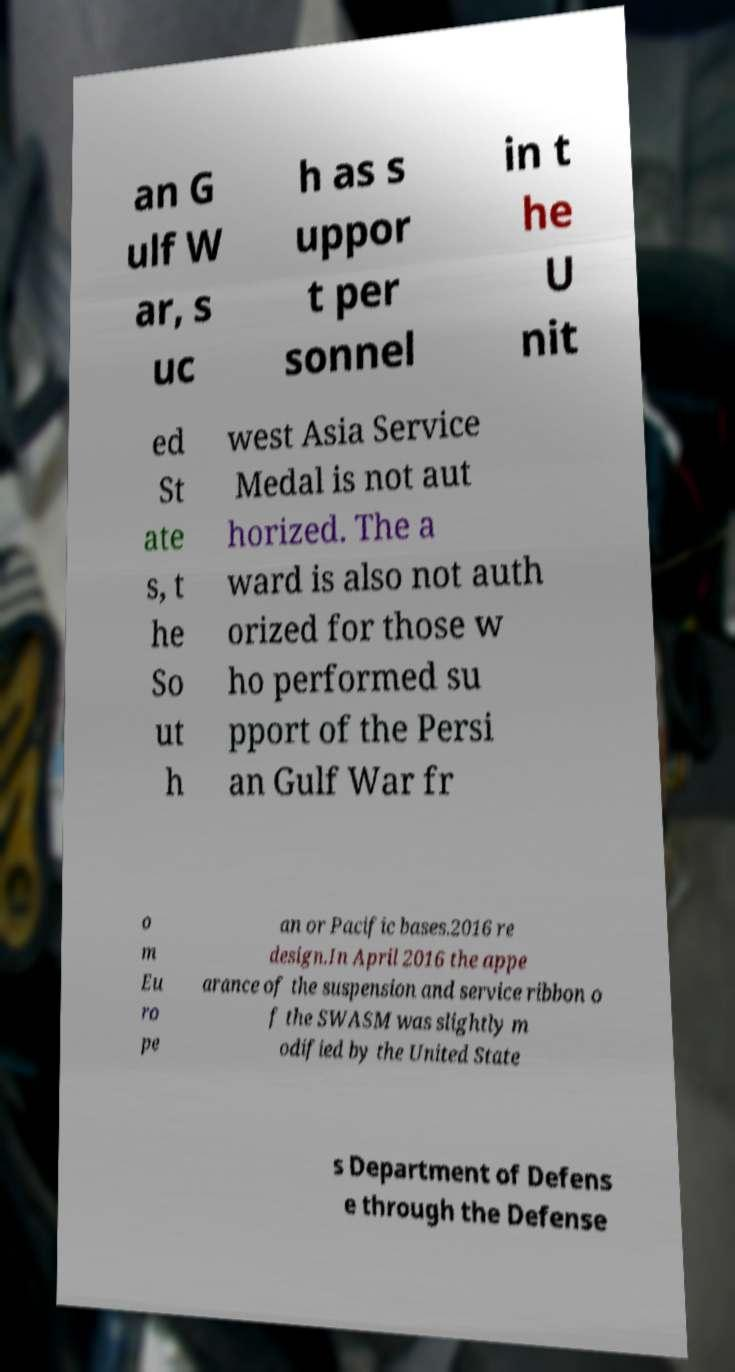For documentation purposes, I need the text within this image transcribed. Could you provide that? an G ulf W ar, s uc h as s uppor t per sonnel in t he U nit ed St ate s, t he So ut h west Asia Service Medal is not aut horized. The a ward is also not auth orized for those w ho performed su pport of the Persi an Gulf War fr o m Eu ro pe an or Pacific bases.2016 re design.In April 2016 the appe arance of the suspension and service ribbon o f the SWASM was slightly m odified by the United State s Department of Defens e through the Defense 